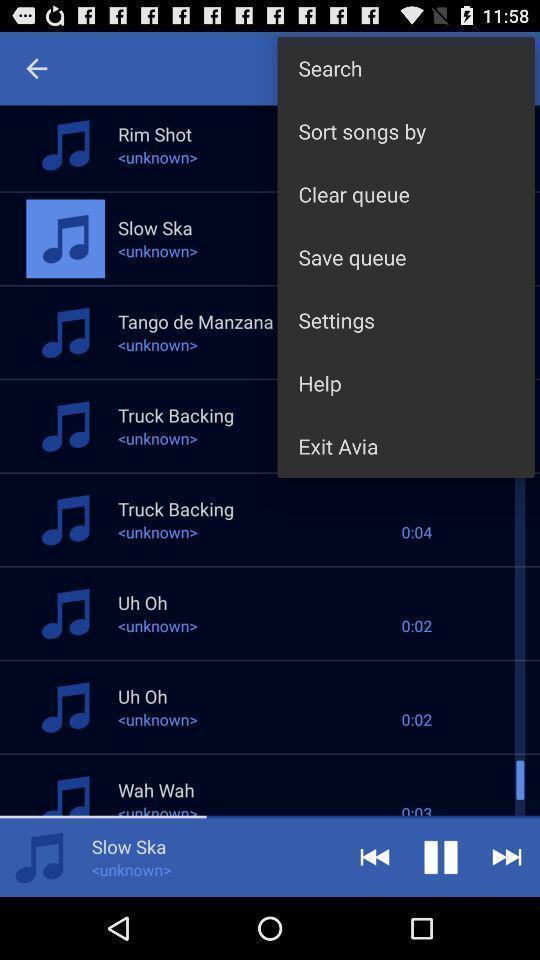What can you discern from this picture? Songs list and playback options. 